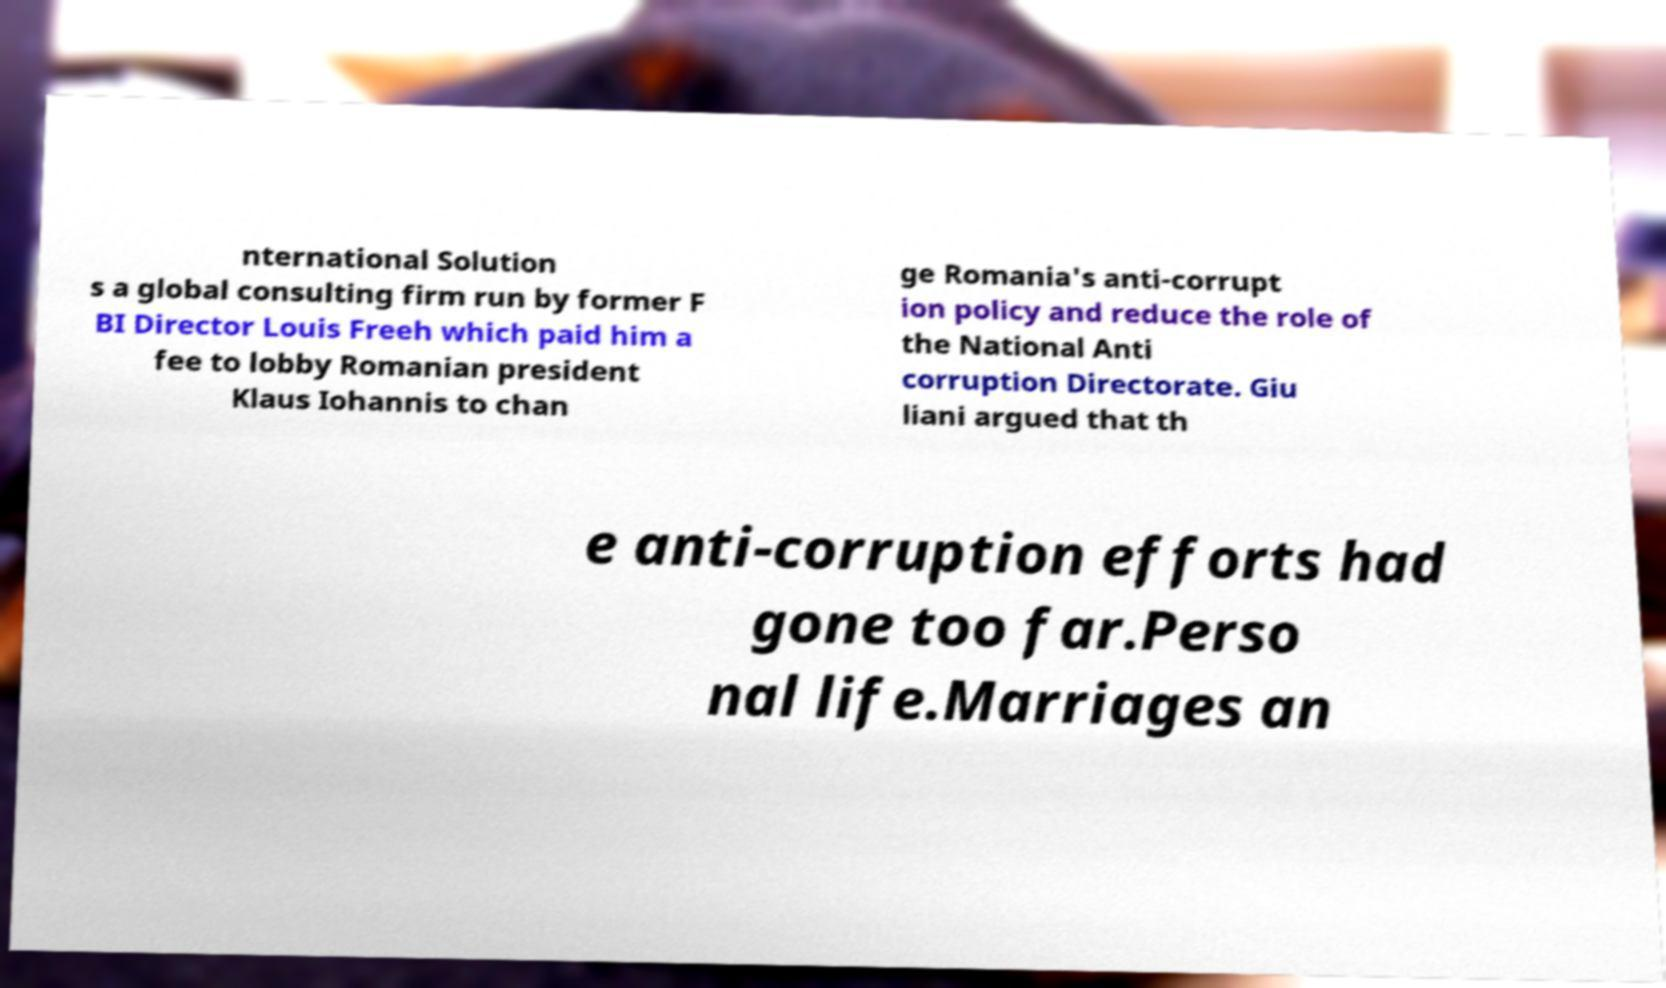Please read and relay the text visible in this image. What does it say? nternational Solution s a global consulting firm run by former F BI Director Louis Freeh which paid him a fee to lobby Romanian president Klaus Iohannis to chan ge Romania's anti-corrupt ion policy and reduce the role of the National Anti corruption Directorate. Giu liani argued that th e anti-corruption efforts had gone too far.Perso nal life.Marriages an 